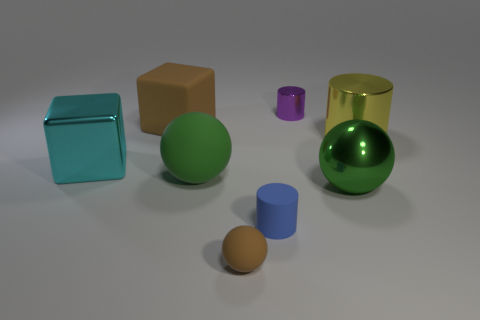Are there fewer green metal balls than cubes?
Give a very brief answer. Yes. There is a big thing that is both behind the large metal cube and on the right side of the tiny matte ball; what material is it?
Provide a short and direct response. Metal. What is the size of the brown object right of the brown rubber object behind the cyan shiny cube left of the small purple cylinder?
Your answer should be compact. Small. There is a tiny blue matte thing; is its shape the same as the big matte thing in front of the brown matte block?
Your answer should be very brief. No. What number of large green objects are both on the right side of the small purple thing and to the left of the small metal cylinder?
Provide a short and direct response. 0. What number of brown things are either large matte balls or large rubber blocks?
Provide a short and direct response. 1. Do the cube that is behind the cyan metallic thing and the tiny cylinder that is behind the big yellow cylinder have the same color?
Offer a terse response. No. There is a small cylinder that is behind the large ball right of the green ball that is left of the purple cylinder; what color is it?
Offer a very short reply. Purple. There is a brown sphere that is to the right of the brown block; are there any brown rubber objects left of it?
Provide a succinct answer. Yes. There is a big green object to the right of the small brown sphere; is it the same shape as the big brown object?
Offer a terse response. No. 